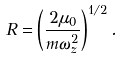<formula> <loc_0><loc_0><loc_500><loc_500>R = \left ( \frac { 2 \mu _ { 0 } } { m \omega _ { z } ^ { 2 } } \right ) ^ { 1 / 2 } .</formula> 